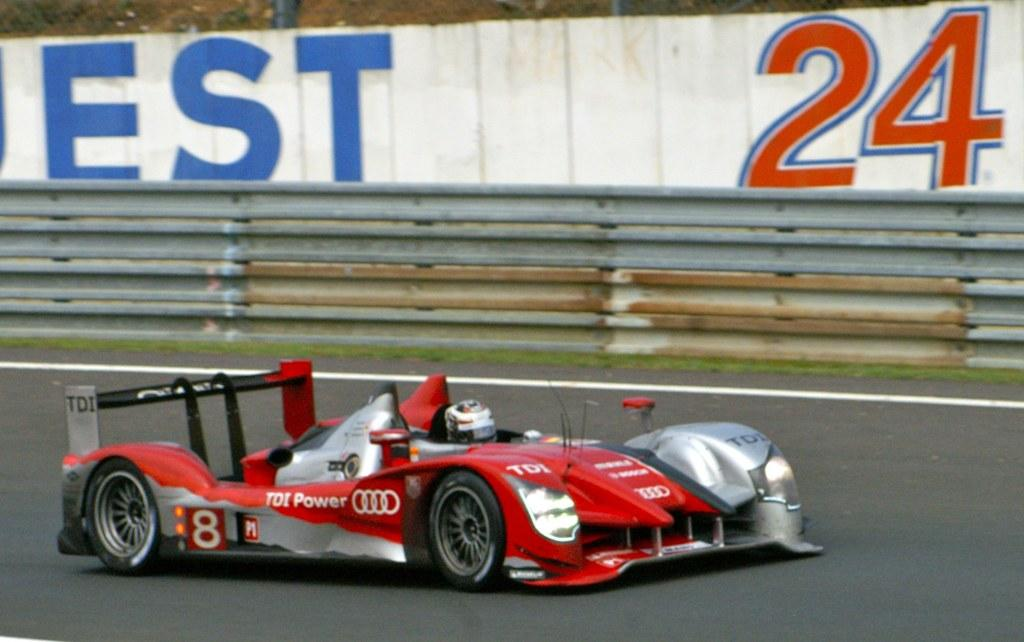What is the person in the image doing? The person is riding a car in the image. What safety precaution is the person taking while riding the car? The person is wearing a helmet. What type of surface can be seen in the image? There is a road in the image. What is the purpose of the hoarding in the image? The hoarding in the image is likely used for advertising or displaying information. What type of barrier is present in the image? There is a fence in the image. What type of vegetation is visible in the image? There is grass visible in the image. How much profit does the land in the image generate? There is no information about the profit generated by the land in the image, as the focus is on the person riding a car and the surrounding environment. 